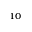<formula> <loc_0><loc_0><loc_500><loc_500>_ { 1 0 }</formula> 